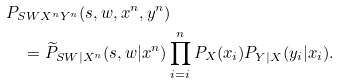Convert formula to latex. <formula><loc_0><loc_0><loc_500><loc_500>& P _ { S W X ^ { n } Y ^ { n } } ( s , w , x ^ { n } , y ^ { n } ) \\ & \quad = \widetilde { P } _ { S W | X ^ { n } } ( s , w | x ^ { n } ) \prod _ { i = i } ^ { n } P _ { X } ( x _ { i } ) P _ { Y | X } ( y _ { i } | x _ { i } ) .</formula> 